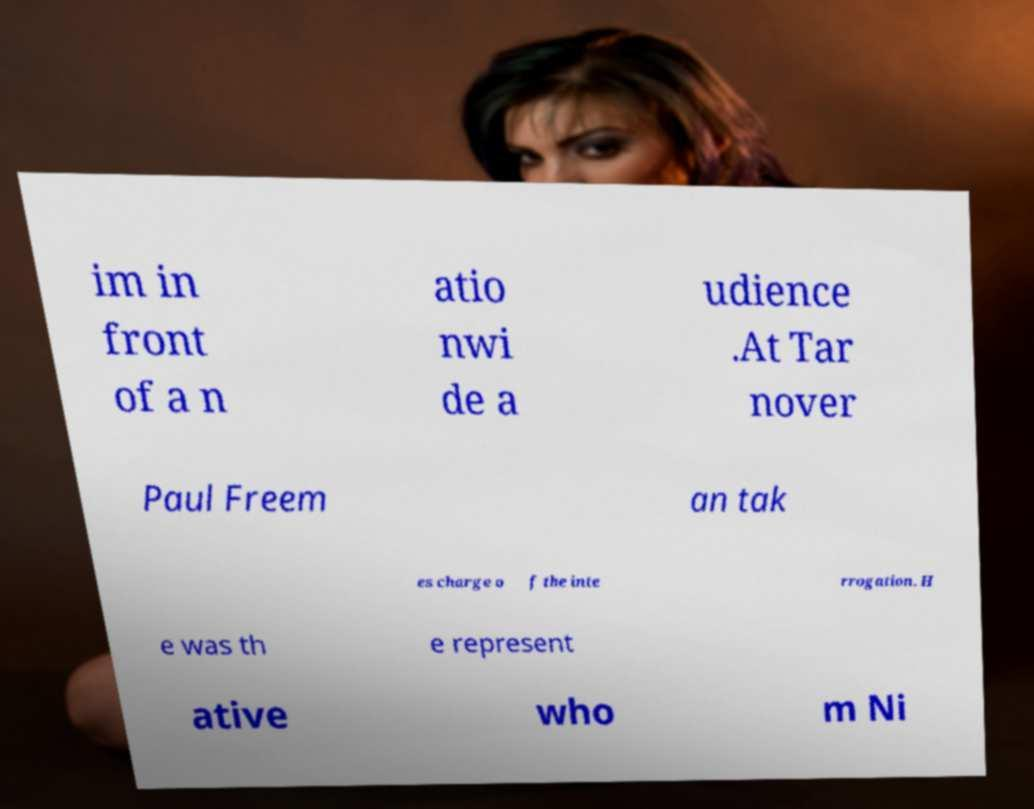Could you assist in decoding the text presented in this image and type it out clearly? im in front of a n atio nwi de a udience .At Tar nover Paul Freem an tak es charge o f the inte rrogation. H e was th e represent ative who m Ni 